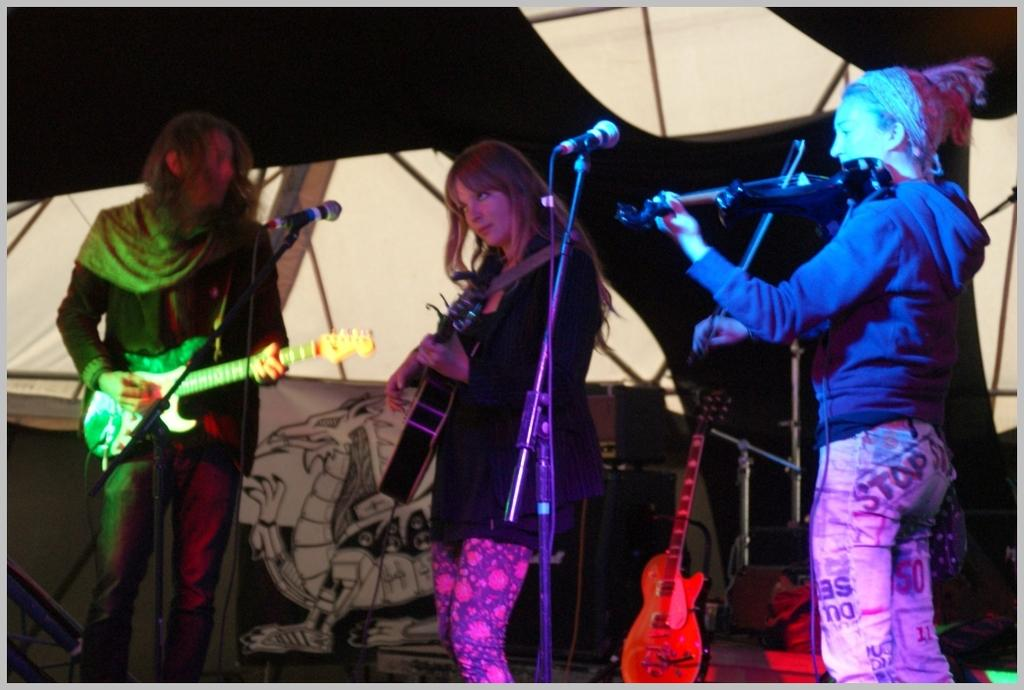What is the main object in the image? There is a banner in the image. How many people are in the image? There are three people in the image. What are the people holding? Each person is holding a guitar. What other objects can be seen in the image? There are microphones (mics) in the image. What type of surprise can be seen on the front of the banner in the image? There is no surprise or front of a banner present in the image; it only shows a banner with people holding guitars and microphones. What type of spade is being used by one of the people in the image? There is no spade present in the image; the people are holding guitars and there are microphones visible. 